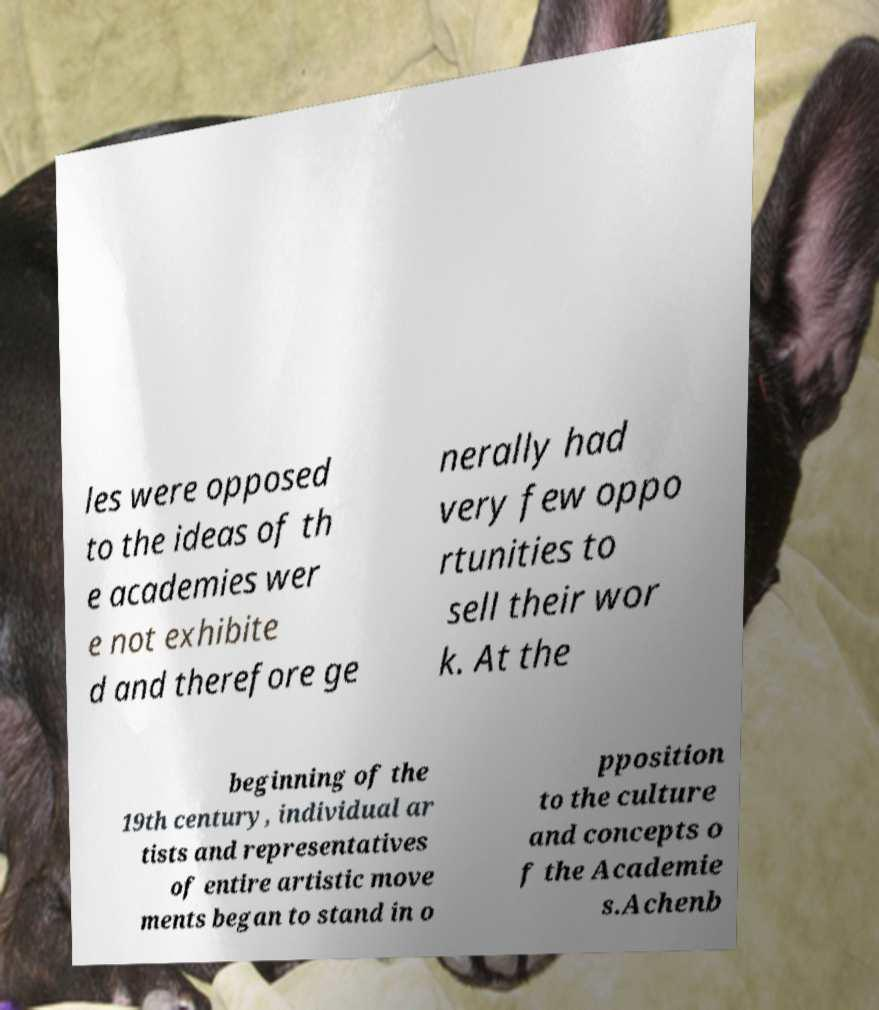Can you read and provide the text displayed in the image?This photo seems to have some interesting text. Can you extract and type it out for me? les were opposed to the ideas of th e academies wer e not exhibite d and therefore ge nerally had very few oppo rtunities to sell their wor k. At the beginning of the 19th century, individual ar tists and representatives of entire artistic move ments began to stand in o pposition to the culture and concepts o f the Academie s.Achenb 